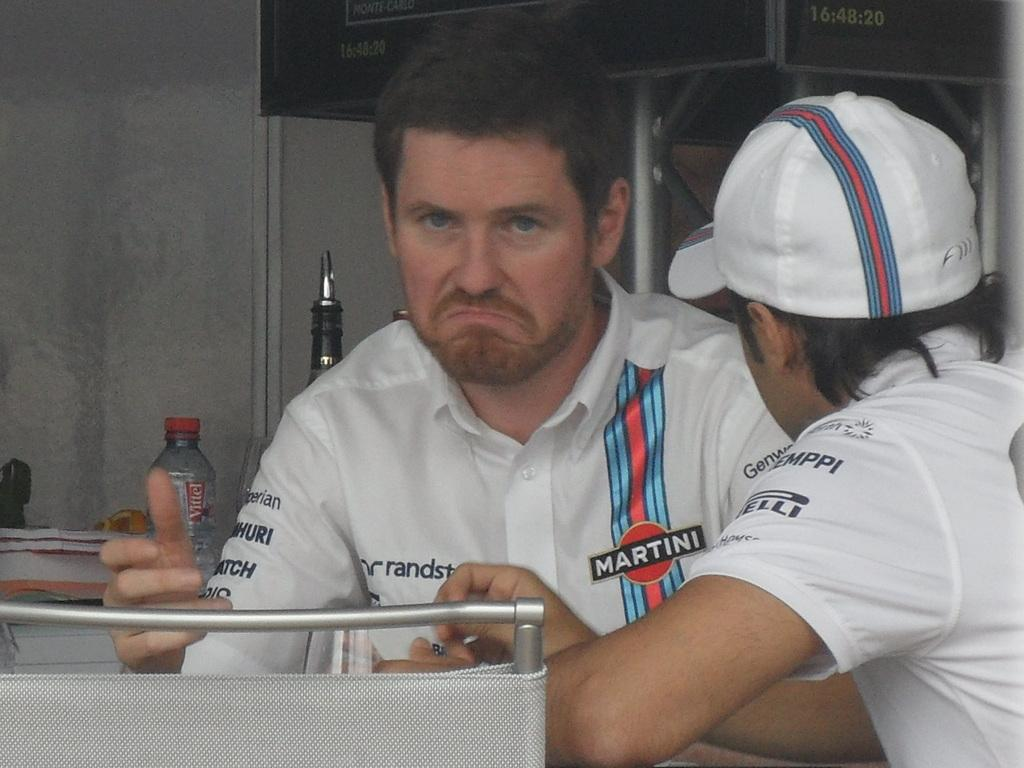How many people are in the image? There are two persons in the image. Can you describe the clothing of one of the persons? One person is wearing a cap. What object can be seen in the image besides the people? There is a bottle in the image. What type of items are present in the image that might be related to learning or reading? There are books in the image. What can be seen in the background of the image? There is a banner in the background of the image. What type of pear is being used to lead the group in the image? There is no pear or any indication of leading a group in the image. 